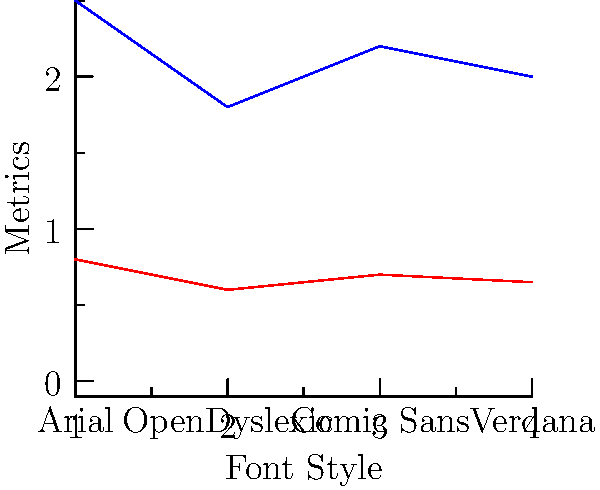Based on the eye-tracking heat map data represented in the graph, which font style appears to be the most effective for dyslexic readers, considering both the number of fixations and fixation duration? To determine the most effective font style for dyslexic readers, we need to analyze both the number of fixations and fixation duration for each font style:

1. Arial:
   - Number of fixations: 2.5 (highest)
   - Fixation duration: 0.8s (longest)

2. OpenDyslexic:
   - Number of fixations: 1.8 (lowest)
   - Fixation duration: 0.6s (shortest)

3. Comic Sans:
   - Number of fixations: 2.2
   - Fixation duration: 0.7s

4. Verdana:
   - Number of fixations: 2.0
   - Fixation duration: 0.65s

For dyslexic readers, fewer fixations and shorter fixation durations generally indicate better readability and comprehension. This is because:

a) Fewer fixations suggest that readers can process more information in each glance.
b) Shorter fixation durations indicate that readers can quickly recognize and process words.

OpenDyslexic has both the lowest number of fixations (1.8) and the shortest fixation duration (0.6s), making it the most effective font style for dyslexic readers according to this data.

Verdana comes in second, followed by Comic Sans, with Arial being the least effective based on these metrics.
Answer: OpenDyslexic 